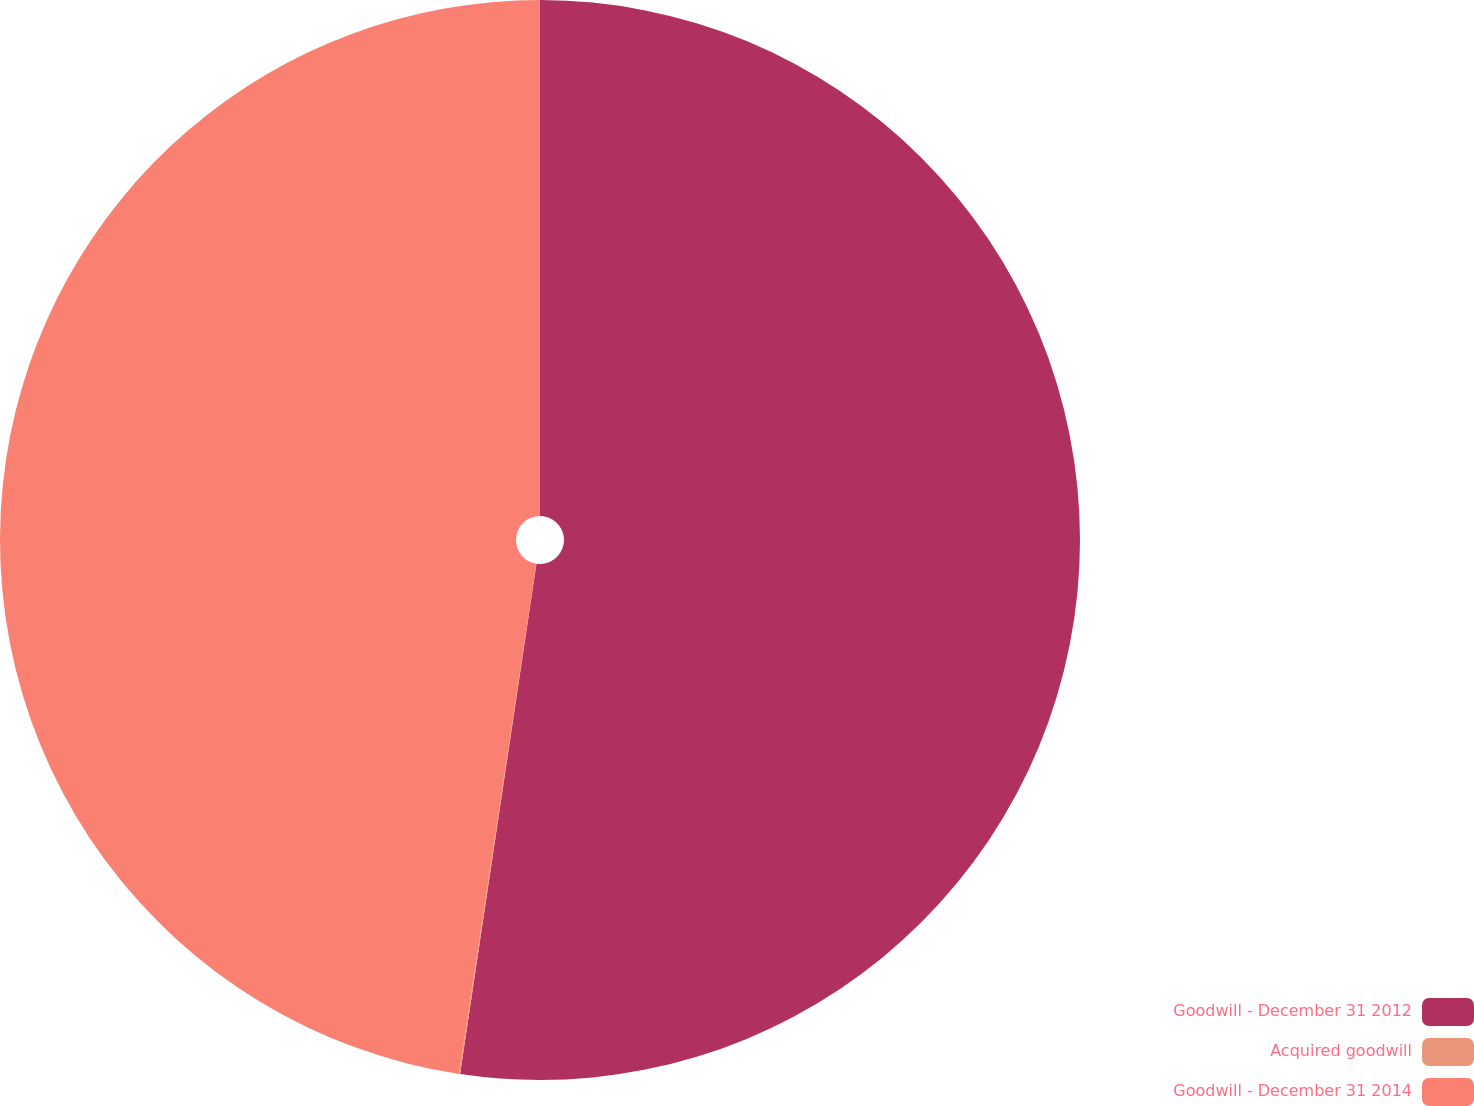Convert chart to OTSL. <chart><loc_0><loc_0><loc_500><loc_500><pie_chart><fcel>Goodwill - December 31 2012<fcel>Acquired goodwill<fcel>Goodwill - December 31 2014<nl><fcel>52.37%<fcel>0.03%<fcel>47.61%<nl></chart> 